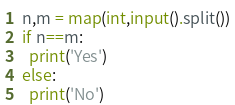Convert code to text. <code><loc_0><loc_0><loc_500><loc_500><_Python_>n,m = map(int,input().split())
if n==m:
  print('Yes')
else:
  print('No')</code> 